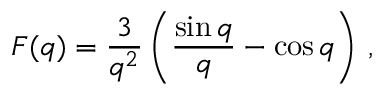<formula> <loc_0><loc_0><loc_500><loc_500>F ( q ) = \frac { 3 } { q ^ { 2 } } \left ( \frac { \sin q } { q } - \cos q \right ) \, ,</formula> 